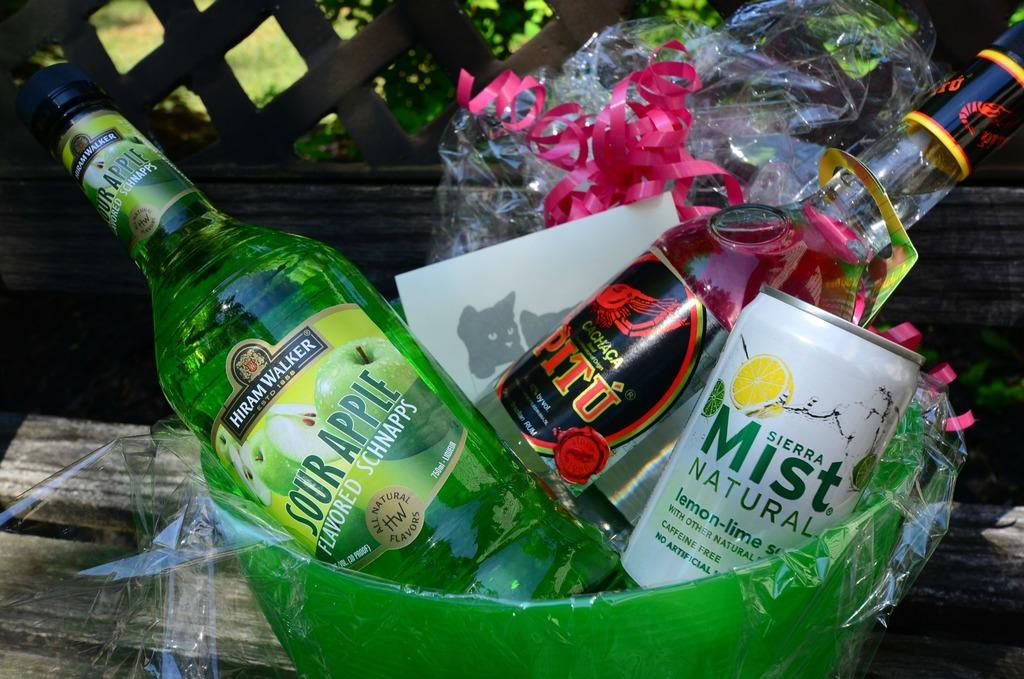<image>
Create a compact narrative representing the image presented. A green basket with a can of Sierra mist natural drink next to two other bottles. 